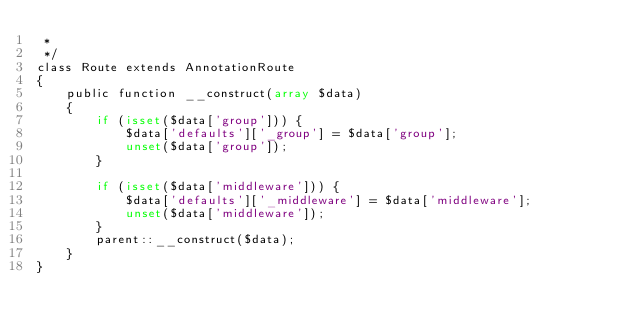<code> <loc_0><loc_0><loc_500><loc_500><_PHP_> *
 */
class Route extends AnnotationRoute 
{
    public function __construct(array $data)
    {
        if (isset($data['group'])) {
            $data['defaults']['_group'] = $data['group'];
            unset($data['group']);
        }

        if (isset($data['middleware'])) {
            $data['defaults']['_middleware'] = $data['middleware'];
            unset($data['middleware']);
        }
        parent::__construct($data);
    }
}</code> 